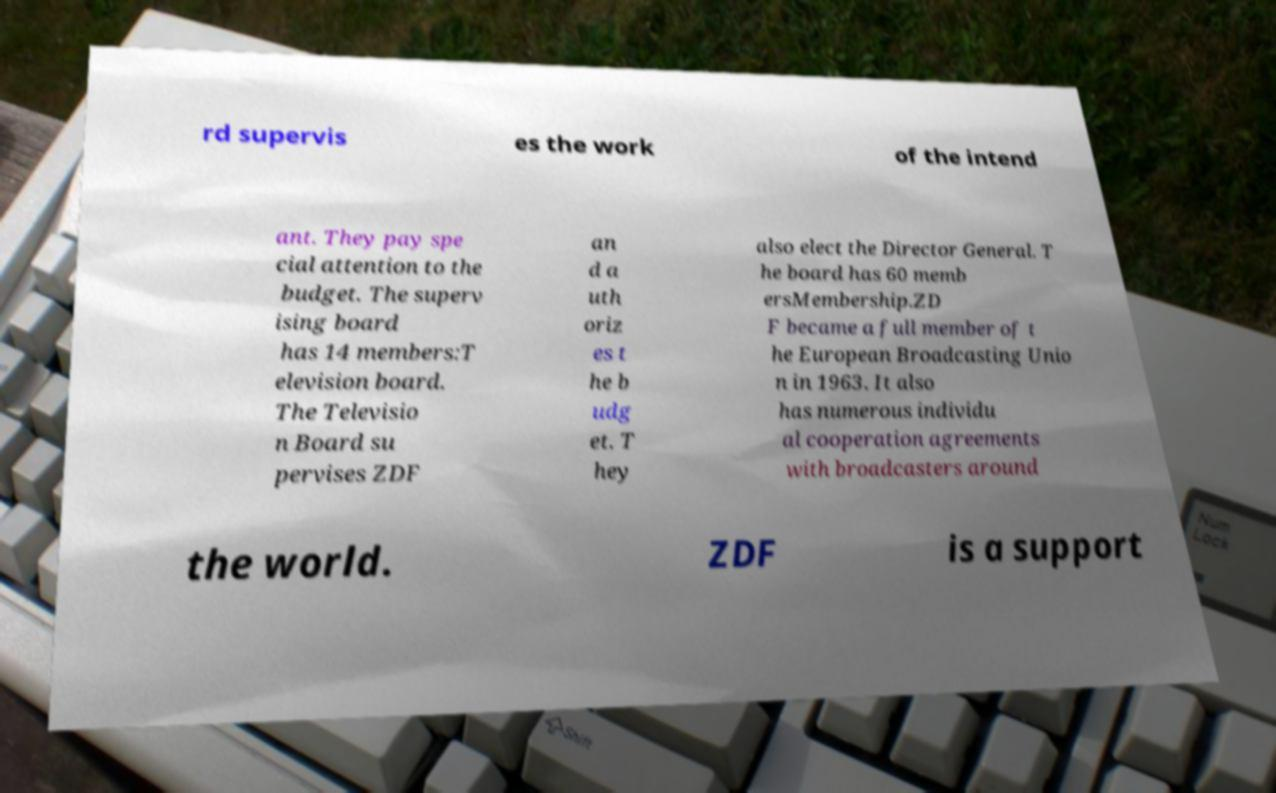For documentation purposes, I need the text within this image transcribed. Could you provide that? rd supervis es the work of the intend ant. They pay spe cial attention to the budget. The superv ising board has 14 members:T elevision board. The Televisio n Board su pervises ZDF an d a uth oriz es t he b udg et. T hey also elect the Director General. T he board has 60 memb ersMembership.ZD F became a full member of t he European Broadcasting Unio n in 1963. It also has numerous individu al cooperation agreements with broadcasters around the world. ZDF is a support 